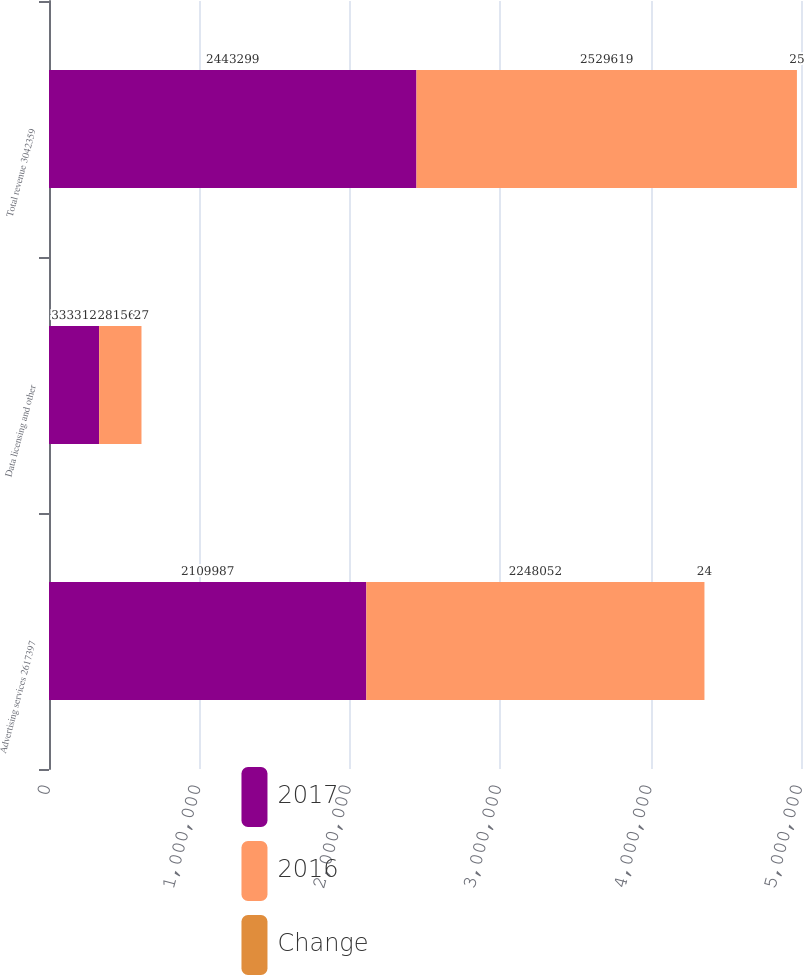Convert chart. <chart><loc_0><loc_0><loc_500><loc_500><stacked_bar_chart><ecel><fcel>Advertising services 2617397<fcel>Data licensing and other<fcel>Total revenue 3042359<nl><fcel>2017<fcel>2.10999e+06<fcel>333312<fcel>2.4433e+06<nl><fcel>2016<fcel>2.24805e+06<fcel>281567<fcel>2.52962e+06<nl><fcel>Change<fcel>24<fcel>27<fcel>25<nl></chart> 